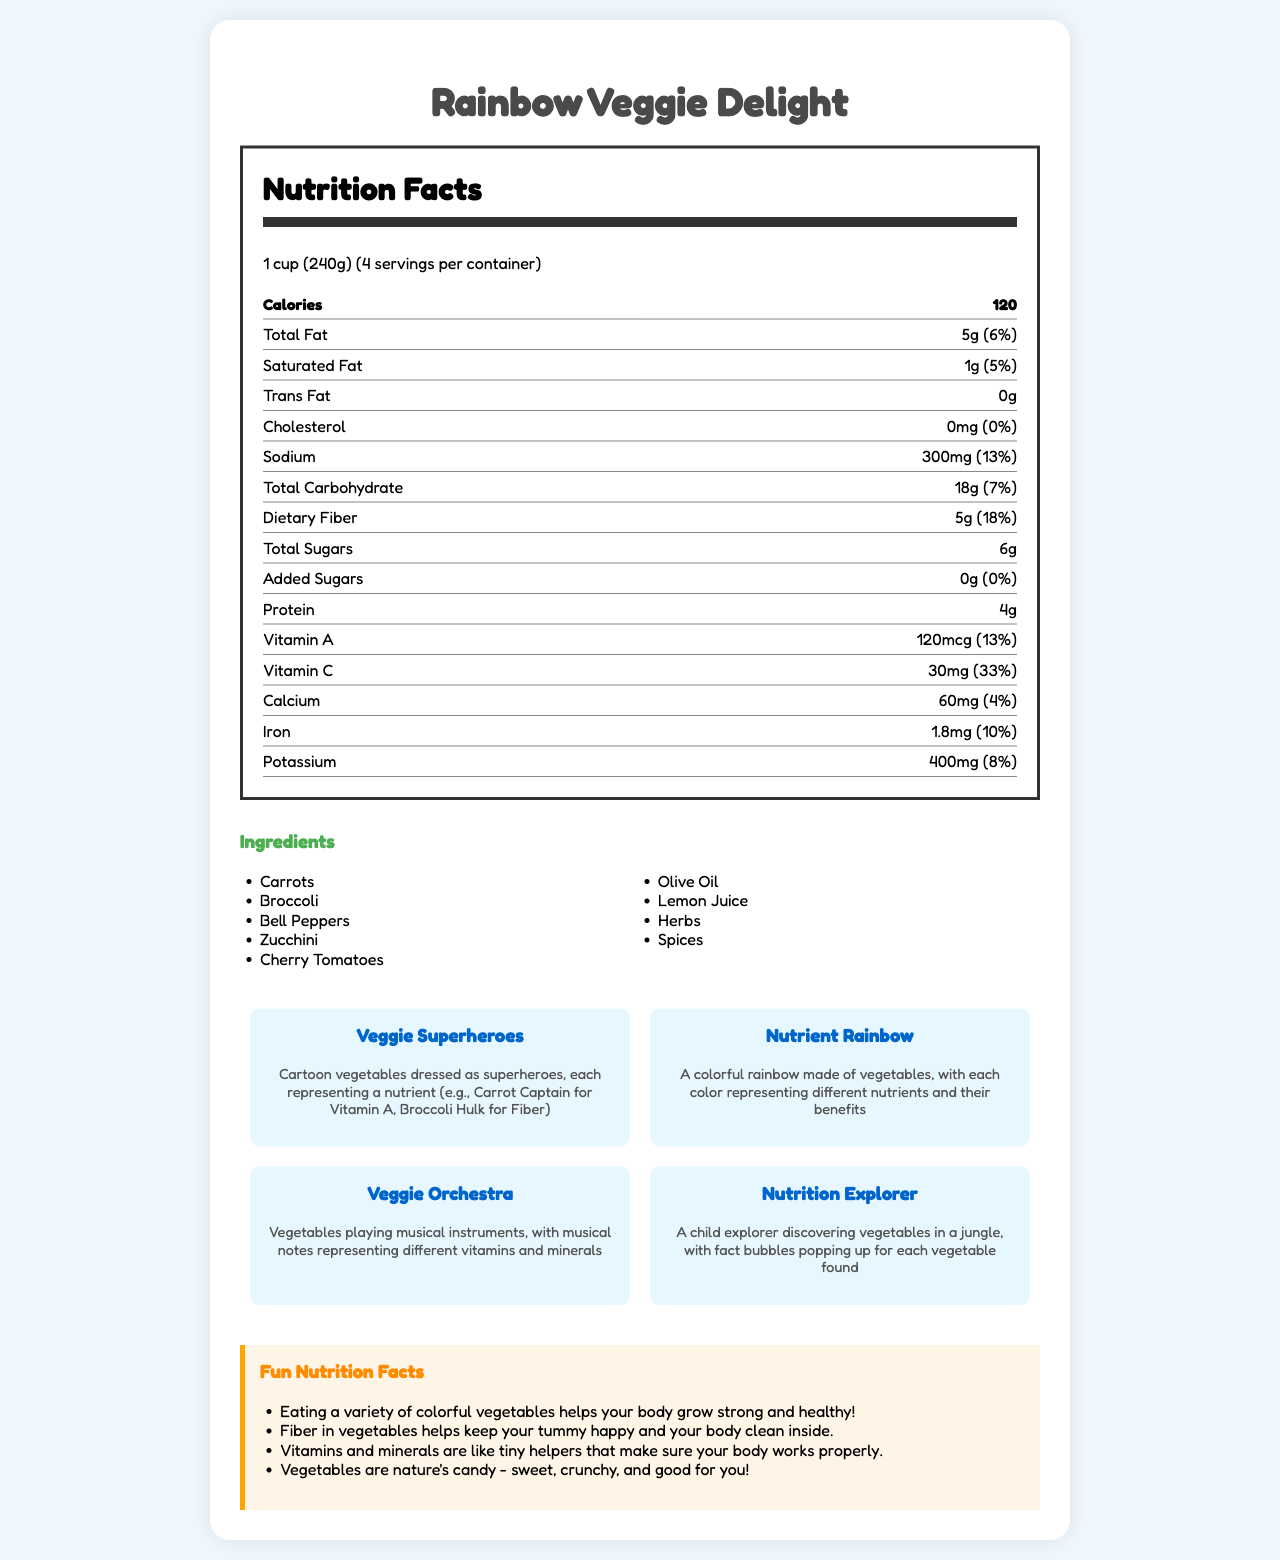what is the serving size of Rainbow Veggie Delight? The serving size is mentioned at the top of the nutrition facts section as "1 cup (240g)".
Answer: 1 cup (240g) how many calories are there per serving? The calories per serving are displayed prominently in the nutrition label.
Answer: 120 which nutrient is represented by the "Carrot Captain" in the Veggie Superheroes illustration? The "Carrot Captain" represents Vitamin A as indicated in the creative illustrations section.
Answer: Vitamin A what percentage of daily Vitamin C is provided per serving? The nutrition label section lists that each serving provides 33% of the daily value for Vitamin C.
Answer: 33% what is the amount of dietary fiber per serving? The nutrition label shows that each serving contains 5g of dietary fiber.
Answer: 5g which vegetables are listed in the ingredients? A. Carrots, Broccoli, Bell Peppers B. Bell Peppers, Zucchini, Lemon Juice C. All of the above The ingredients list includes Carrots, Broccoli, Bell Peppers, Zucchini, Cherry Tomatoes, Olive Oil, Lemon Juice, Herbs, and Spices.
Answer: C how many grams of trans fat are in one serving of Rainbow Veggie Delight? A. 5g B. 2g C. 0g The nutrition label states that there are 0g of trans fat per serving.
Answer: C does the Rainbow Veggie Delight contain any common allergens? The allergen information mentioned that it contains no common allergens.
Answer: No is Olive Oil one of the ingredients in the Rainbow Veggie Delight? Olive Oil is listed in the ingredients.
Answer: Yes summarize the main idea of the document. The document gives a comprehensive overview of the Rainbow Veggie Delight dish, its nutritional facts, ingredients, and creative illustrations meant to make nutritional learning fun and engaging for children. It also includes educational notes and interactive elements to further enhance children's understanding of nutrition.
Answer: Rainbow Veggie Delight is a vegetable-based dish with a variety of ingredients like carrots, broccoli, and bell peppers. The nutrition label provides detailed information on calories, fats, sodium, carbohydrates, fiber, protein, and vitamins. Creative illustrations are used to make the nutritional information engaging for children, including Veggie Superheroes and a Veggie Orchestra. Educational notes and interactive elements help kids learn about nutrition in a fun way. what is the total amount of sodium (in grams) in the entire container? The document only provides the sodium per serving (300mg) and the number of servings per container (4), but does not directly list the total sodium amount. The total can be calculated but is not visually presented.
Answer: Cannot be determined what is the primary goal of including creative illustrations in the document? A. To showcase different vegetables B. To make nutritional information more engaging for children C. To highlight ingredients' taste Creative illustrations like Veggie Superheroes and Veggie Orchestra are meant to make the nutritional information more engaging and fun for children, as described in the document.
Answer: B how much potassium is there per serving, and what percent of daily value does this represent? Each serving contains 400mg of potassium, which represents 8% of the daily value, as noted in the nutrition label section.
Answer: 400mg, 8% 